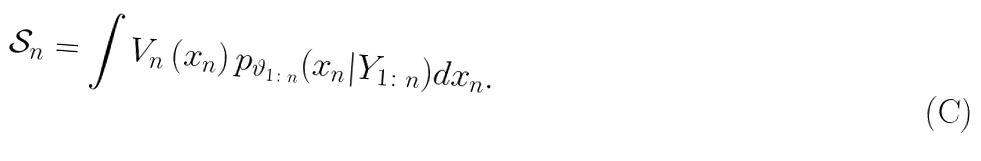<formula> <loc_0><loc_0><loc_500><loc_500>\mathcal { S } _ { n } = \int V _ { n } \left ( x _ { n } \right ) p _ { \vartheta _ { 1 \colon n } } ( x _ { n } | Y _ { 1 \colon n } ) d x _ { n } .</formula> 